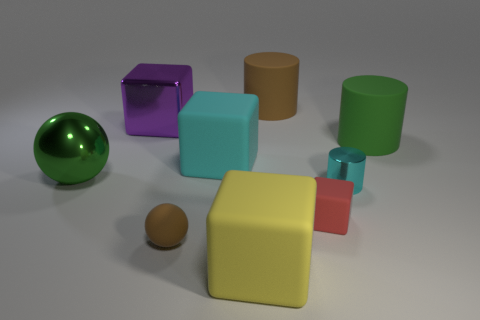Is there a cyan matte object of the same shape as the big yellow rubber thing?
Your response must be concise. Yes. The big object that is to the right of the tiny rubber object right of the large brown rubber object is what shape?
Keep it short and to the point. Cylinder. The large green shiny thing that is in front of the big brown matte cylinder has what shape?
Give a very brief answer. Sphere. There is a big rubber cube that is behind the big green metallic ball; is its color the same as the rubber cylinder that is on the left side of the large green cylinder?
Offer a very short reply. No. How many large cylinders are both in front of the purple metal thing and behind the green cylinder?
Keep it short and to the point. 0. There is a red cube that is the same material as the brown ball; what is its size?
Provide a succinct answer. Small. The shiny sphere has what size?
Make the answer very short. Large. What material is the small cyan cylinder?
Your response must be concise. Metal. There is a brown rubber thing that is in front of the green metallic ball; is its size the same as the big brown thing?
Make the answer very short. No. How many objects are either small blocks or big red shiny blocks?
Ensure brevity in your answer.  1. 